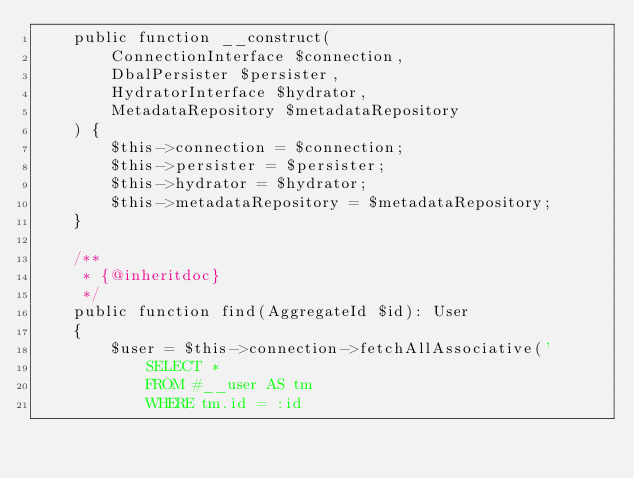<code> <loc_0><loc_0><loc_500><loc_500><_PHP_>    public function __construct(
        ConnectionInterface $connection,
        DbalPersister $persister,
        HydratorInterface $hydrator,
        MetadataRepository $metadataRepository
    ) {
        $this->connection = $connection;
        $this->persister = $persister;
        $this->hydrator = $hydrator;
        $this->metadataRepository = $metadataRepository;
    }

    /**
     * {@inheritdoc}
     */
    public function find(AggregateId $id): User
    {
        $user = $this->connection->fetchAllAssociative('
            SELECT *
            FROM #__user AS tm
            WHERE tm.id = :id</code> 